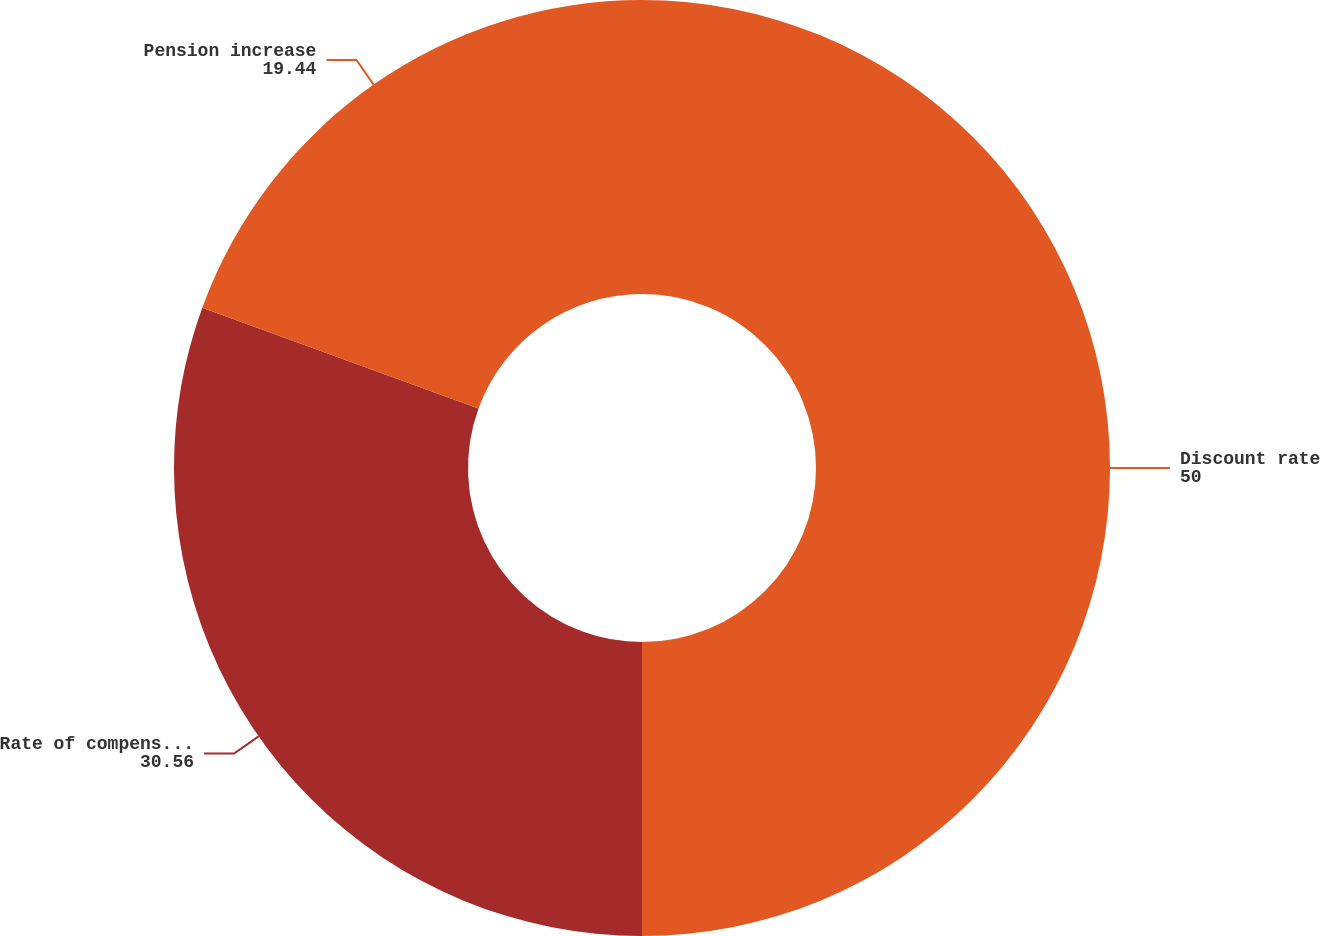Convert chart. <chart><loc_0><loc_0><loc_500><loc_500><pie_chart><fcel>Discount rate<fcel>Rate of compensation increase<fcel>Pension increase<nl><fcel>50.0%<fcel>30.56%<fcel>19.44%<nl></chart> 